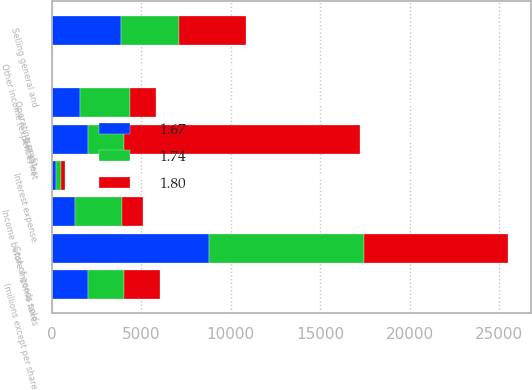Convert chart. <chart><loc_0><loc_0><loc_500><loc_500><stacked_bar_chart><ecel><fcel>(millions except per share<fcel>Net sales<fcel>Cost of goods sold<fcel>Selling general and<fcel>Operating profit<fcel>Interest expense<fcel>Other income (expense) net<fcel>Income before income taxes<nl><fcel>1.74<fcel>2013<fcel>2011.5<fcel>8689<fcel>3266<fcel>2837<fcel>235<fcel>4<fcel>2606<nl><fcel>1.67<fcel>2012<fcel>2011.5<fcel>8763<fcel>3872<fcel>1562<fcel>261<fcel>24<fcel>1325<nl><fcel>1.8<fcel>2011<fcel>13198<fcel>8046<fcel>3725<fcel>1427<fcel>233<fcel>10<fcel>1184<nl></chart> 